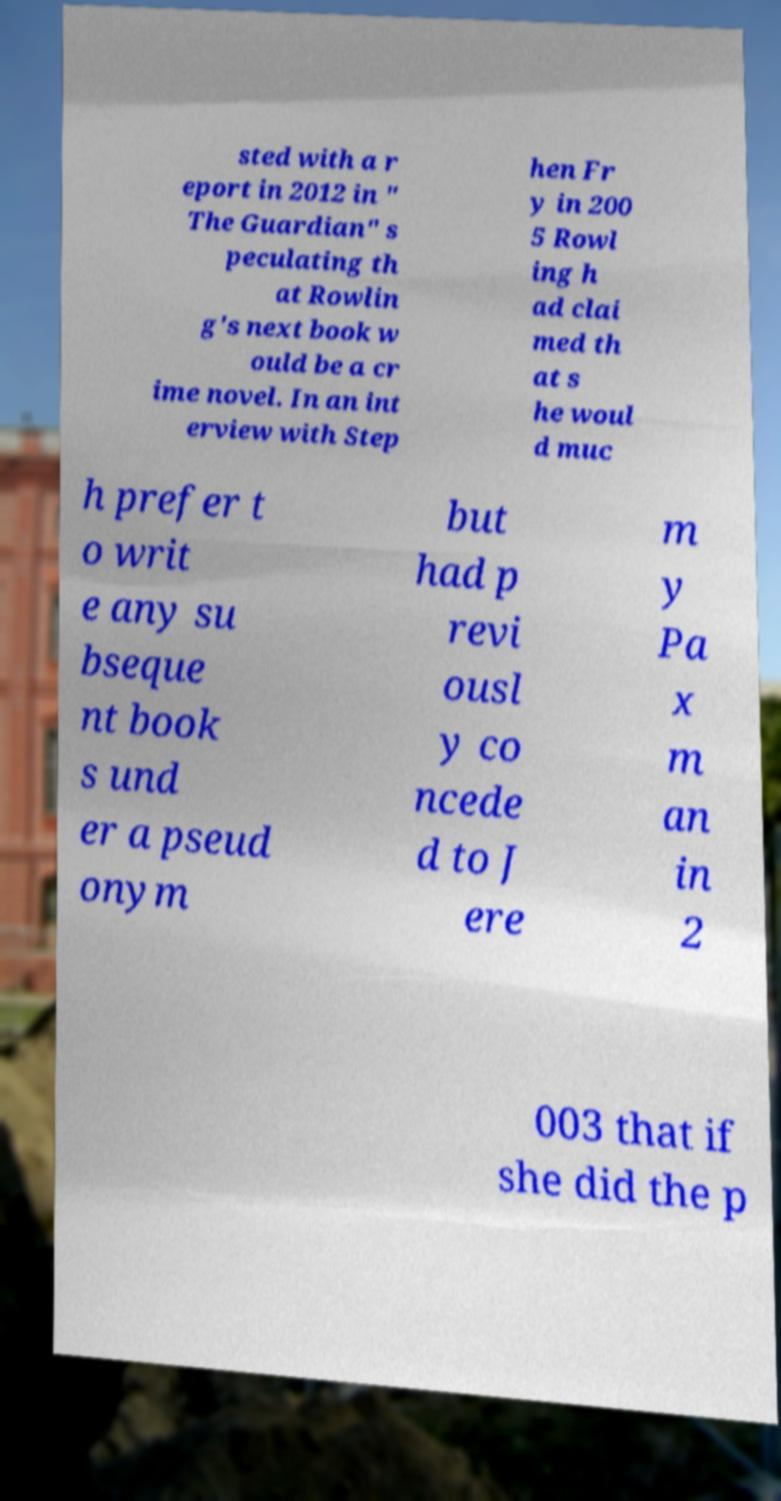I need the written content from this picture converted into text. Can you do that? sted with a r eport in 2012 in " The Guardian" s peculating th at Rowlin g's next book w ould be a cr ime novel. In an int erview with Step hen Fr y in 200 5 Rowl ing h ad clai med th at s he woul d muc h prefer t o writ e any su bseque nt book s und er a pseud onym but had p revi ousl y co ncede d to J ere m y Pa x m an in 2 003 that if she did the p 